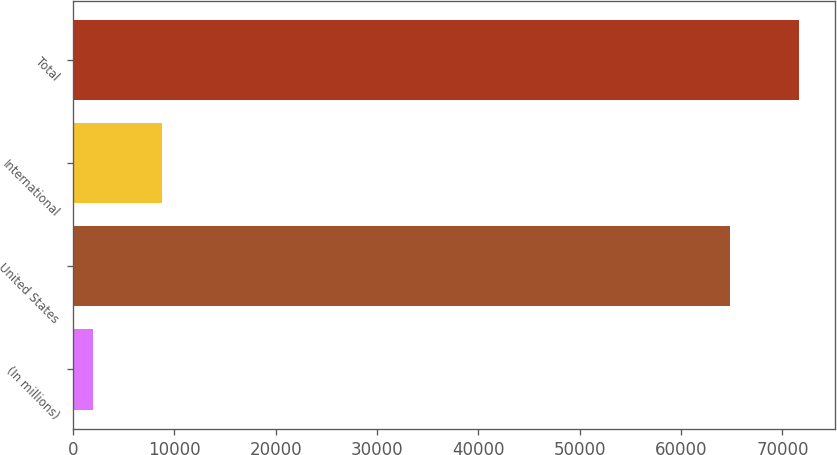Convert chart to OTSL. <chart><loc_0><loc_0><loc_500><loc_500><bar_chart><fcel>(In millions)<fcel>United States<fcel>International<fcel>Total<nl><fcel>2004<fcel>64856.7<fcel>8754.21<fcel>71606.9<nl></chart> 